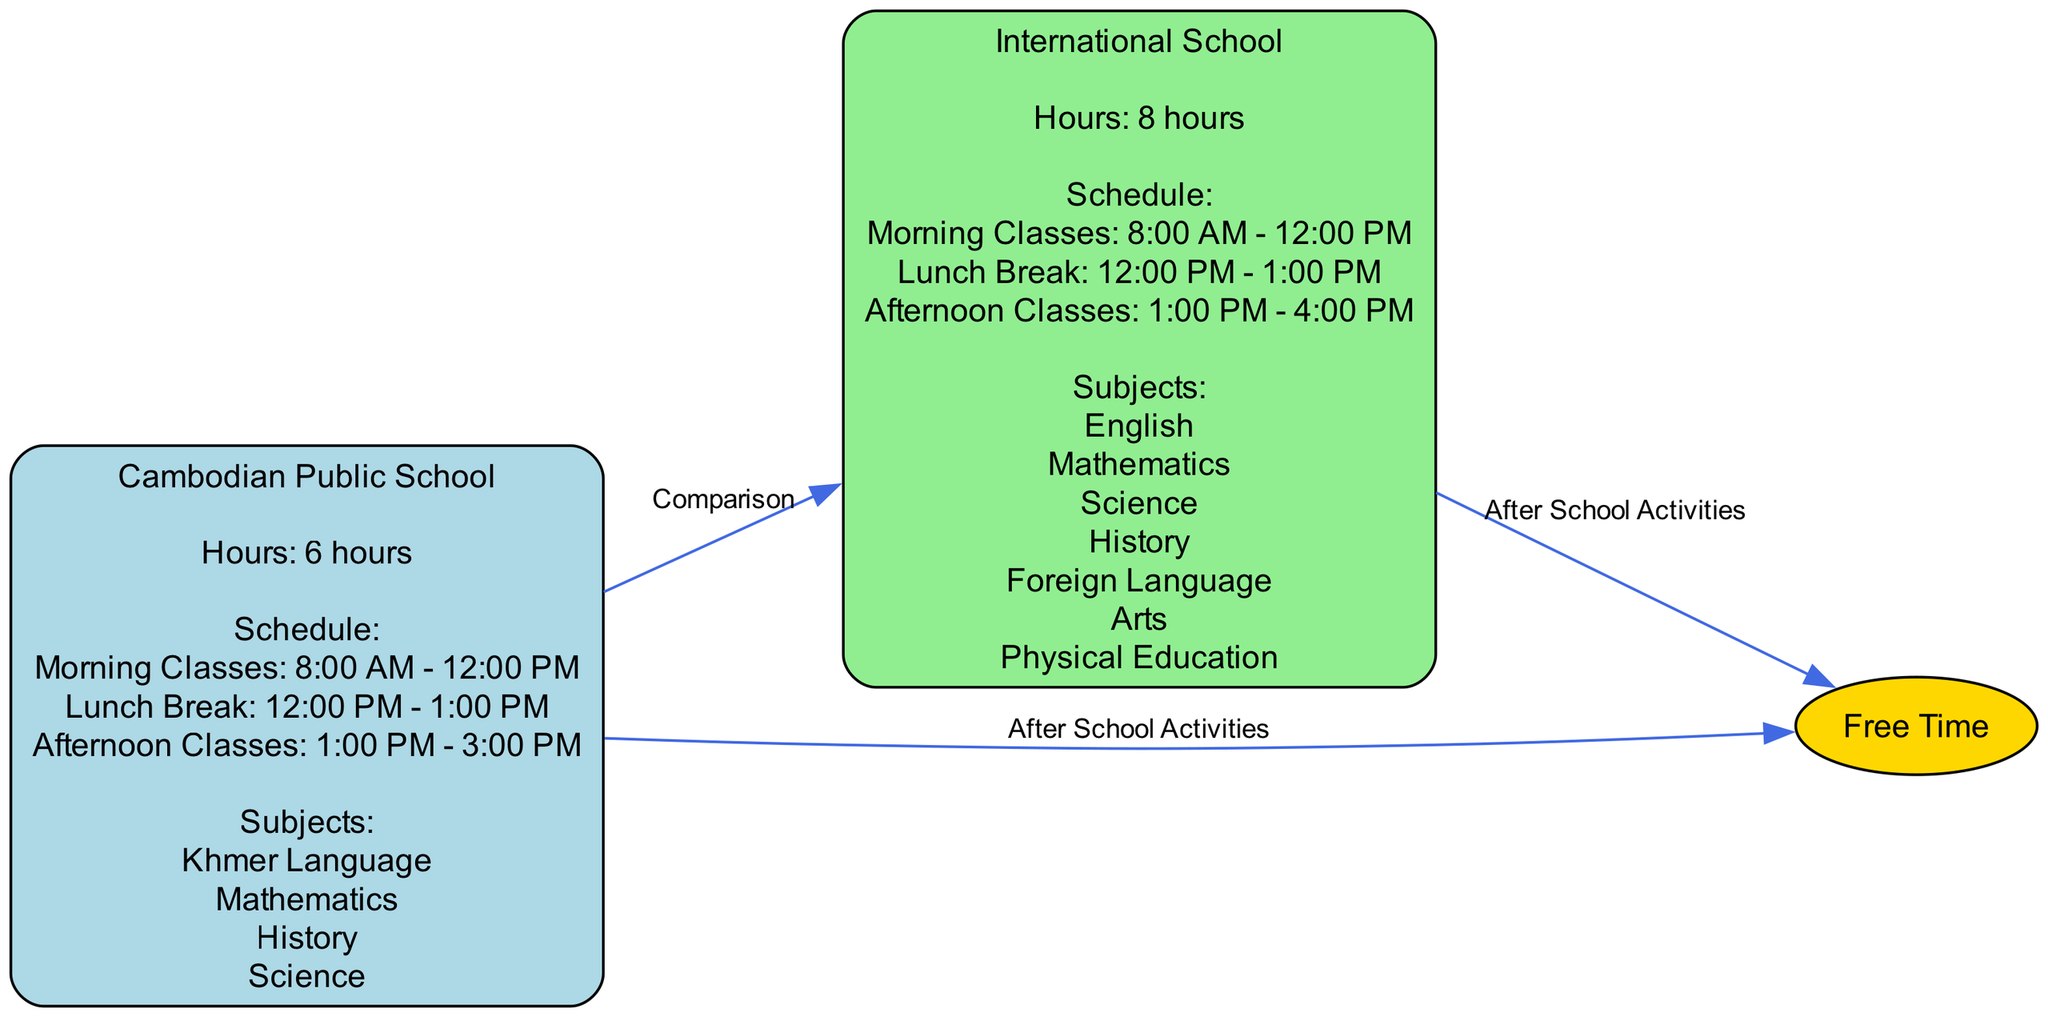What is the total number of hours a student spends in Cambodian public school? The diagram states that the Cambodian public school has a total of 6 hours allocated for classes. This is clearly labeled in the node for Cambodian Public School.
Answer: 6 hours What subjects are taught in the international school? Looking at the attributes of the International School node, the subjects listed are English, Mathematics, Science, History, Foreign Language, Arts, and Physical Education. This can be found under the ‘Subjects’ section of that node.
Answer: English, Mathematics, Science, History, Foreign Language, Arts, Physical Education How long is the lunch break for both schools? The schedule under both the Cambodian Public School and the International School nodes indicates that each school has a lunch break from 12:00 PM to 1:00 PM. This information is the same for both schools as per their respective schedules.
Answer: 1 hour Which school has longer class hours? By comparing the ‘Hours’ attributes of the Cambodian Public School (6 hours) and the International School (8 hours), the International School has longer class hours since 8 is greater than 6.
Answer: International School What time do classes end for the international school? The afternoon classes for the International School are noted to end at 4:00 PM. This is taken from the schedule under the International School node.
Answer: 4:00 PM How many subjects does the Cambodian public school offer? The Cambodian Public School node lists 4 subjects: Khmer Language, Mathematics, History, and Science. Counting them gives a total of four subjects.
Answer: 4 subjects What is the shared duration of free time for both types of schools? The diagram specifies that free time for both the Cambodian Public School and the International School lasts from 4 PM until bedtime. Since this information is common in both cases, the duration can be inferred similarly for both.
Answer: 4 PM - Bedtime What relationship is shown between the Cambodian Public School and Free Time? The diagram indicates a directed edge labeled "After School Activities" that connects the Cambodian Public School to Free Time, suggesting that activities after school lead into the free time allocated.
Answer: After School Activities What additional subject is unique to the international school compared to the Cambodian public school? By comparing the subjects listed under both schools, the International School includes "Foreign Language" and "Arts," which are not present in the Cambodian Public School subjects. Thus, "Foreign Language" is a unique offering.
Answer: Foreign Language 